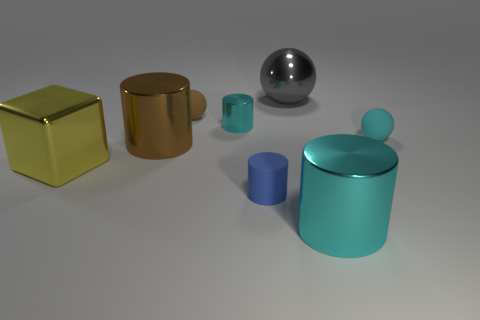What is the color of the metal cylinder right of the small object in front of the brown cylinder?
Ensure brevity in your answer.  Cyan. Are there any other things that are the same size as the gray metallic sphere?
Ensure brevity in your answer.  Yes. Do the thing that is in front of the blue cylinder and the small blue object have the same shape?
Your response must be concise. Yes. How many things are to the left of the blue rubber cylinder and behind the brown shiny cylinder?
Offer a very short reply. 2. What color is the tiny matte cylinder in front of the tiny rubber sphere to the right of the cyan thing in front of the big brown shiny thing?
Make the answer very short. Blue. There is a big shiny object right of the big gray ball; how many cyan balls are left of it?
Your answer should be compact. 0. How many other things are there of the same shape as the tiny brown object?
Give a very brief answer. 2. What number of objects are either small cyan metallic cylinders or small rubber things behind the tiny cyan metallic cylinder?
Keep it short and to the point. 2. Is the number of tiny cylinders that are in front of the large brown metallic object greater than the number of big cubes that are behind the yellow metallic block?
Provide a short and direct response. Yes. The brown thing behind the small rubber ball that is on the right side of the cyan metal cylinder in front of the big brown thing is what shape?
Make the answer very short. Sphere. 